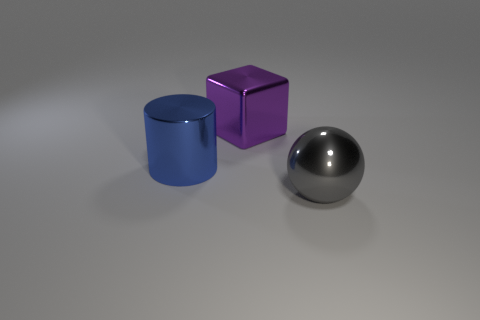Add 1 large purple metal cubes. How many objects exist? 4 Subtract all balls. How many objects are left? 2 Add 2 tiny brown metallic blocks. How many tiny brown metallic blocks exist? 2 Subtract 1 gray balls. How many objects are left? 2 Subtract all blue cylinders. Subtract all big purple things. How many objects are left? 1 Add 3 gray metal objects. How many gray metal objects are left? 4 